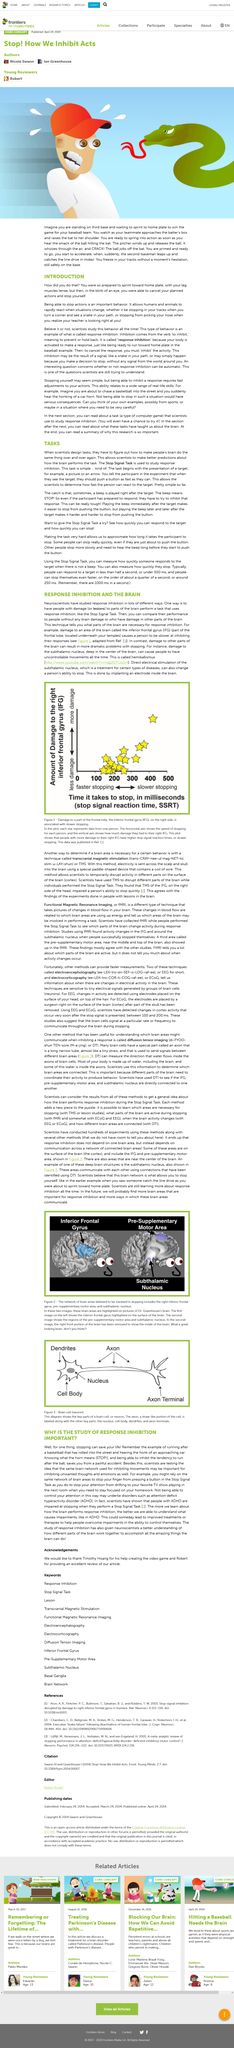Point out several critical features in this image. Scientists use tasks to improve their predictions about how the brain functions in certain situations. A scientific task is a design created by a scientist that employs repetitive brain activity in people. The ability to rapidly react is what allows humans and animals to effectively respond to situations. This is made possible by the ability to quickly stop, which enables us to respond to changing circumstances with agility and efficiency. The article mentions a slithery animal, which is a snake. The Stop Signal Task is used to study response inhibition, which is the ability to stop a planned action in favor of a competing one. 